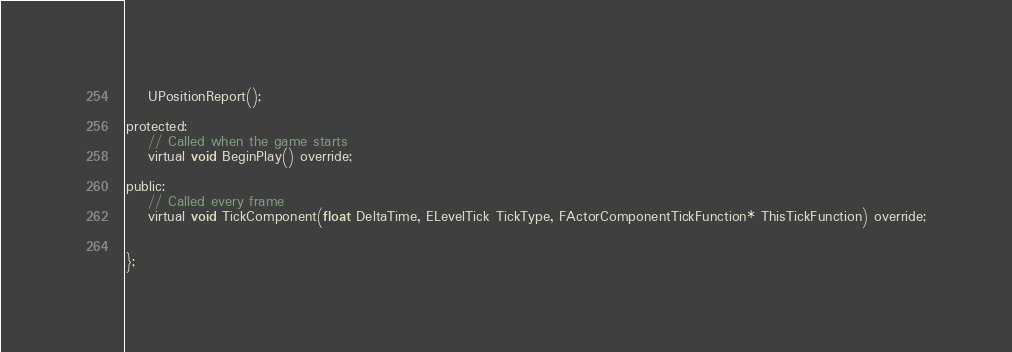<code> <loc_0><loc_0><loc_500><loc_500><_C_>	UPositionReport();

protected:
	// Called when the game starts
	virtual void BeginPlay() override;

public:	
	// Called every frame
	virtual void TickComponent(float DeltaTime, ELevelTick TickType, FActorComponentTickFunction* ThisTickFunction) override;

		
};
</code> 